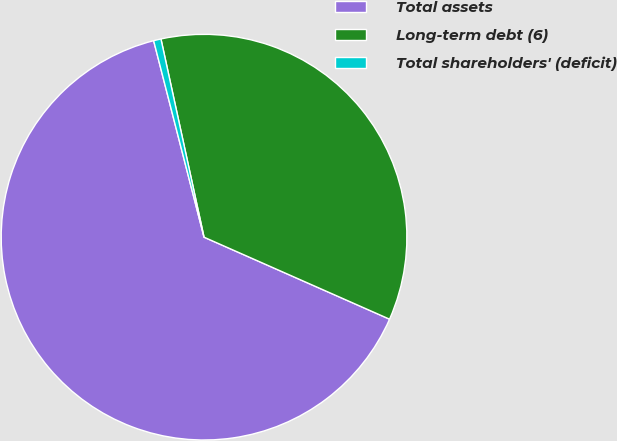<chart> <loc_0><loc_0><loc_500><loc_500><pie_chart><fcel>Total assets<fcel>Long-term debt (6)<fcel>Total shareholders' (deficit)<nl><fcel>64.38%<fcel>35.03%<fcel>0.59%<nl></chart> 